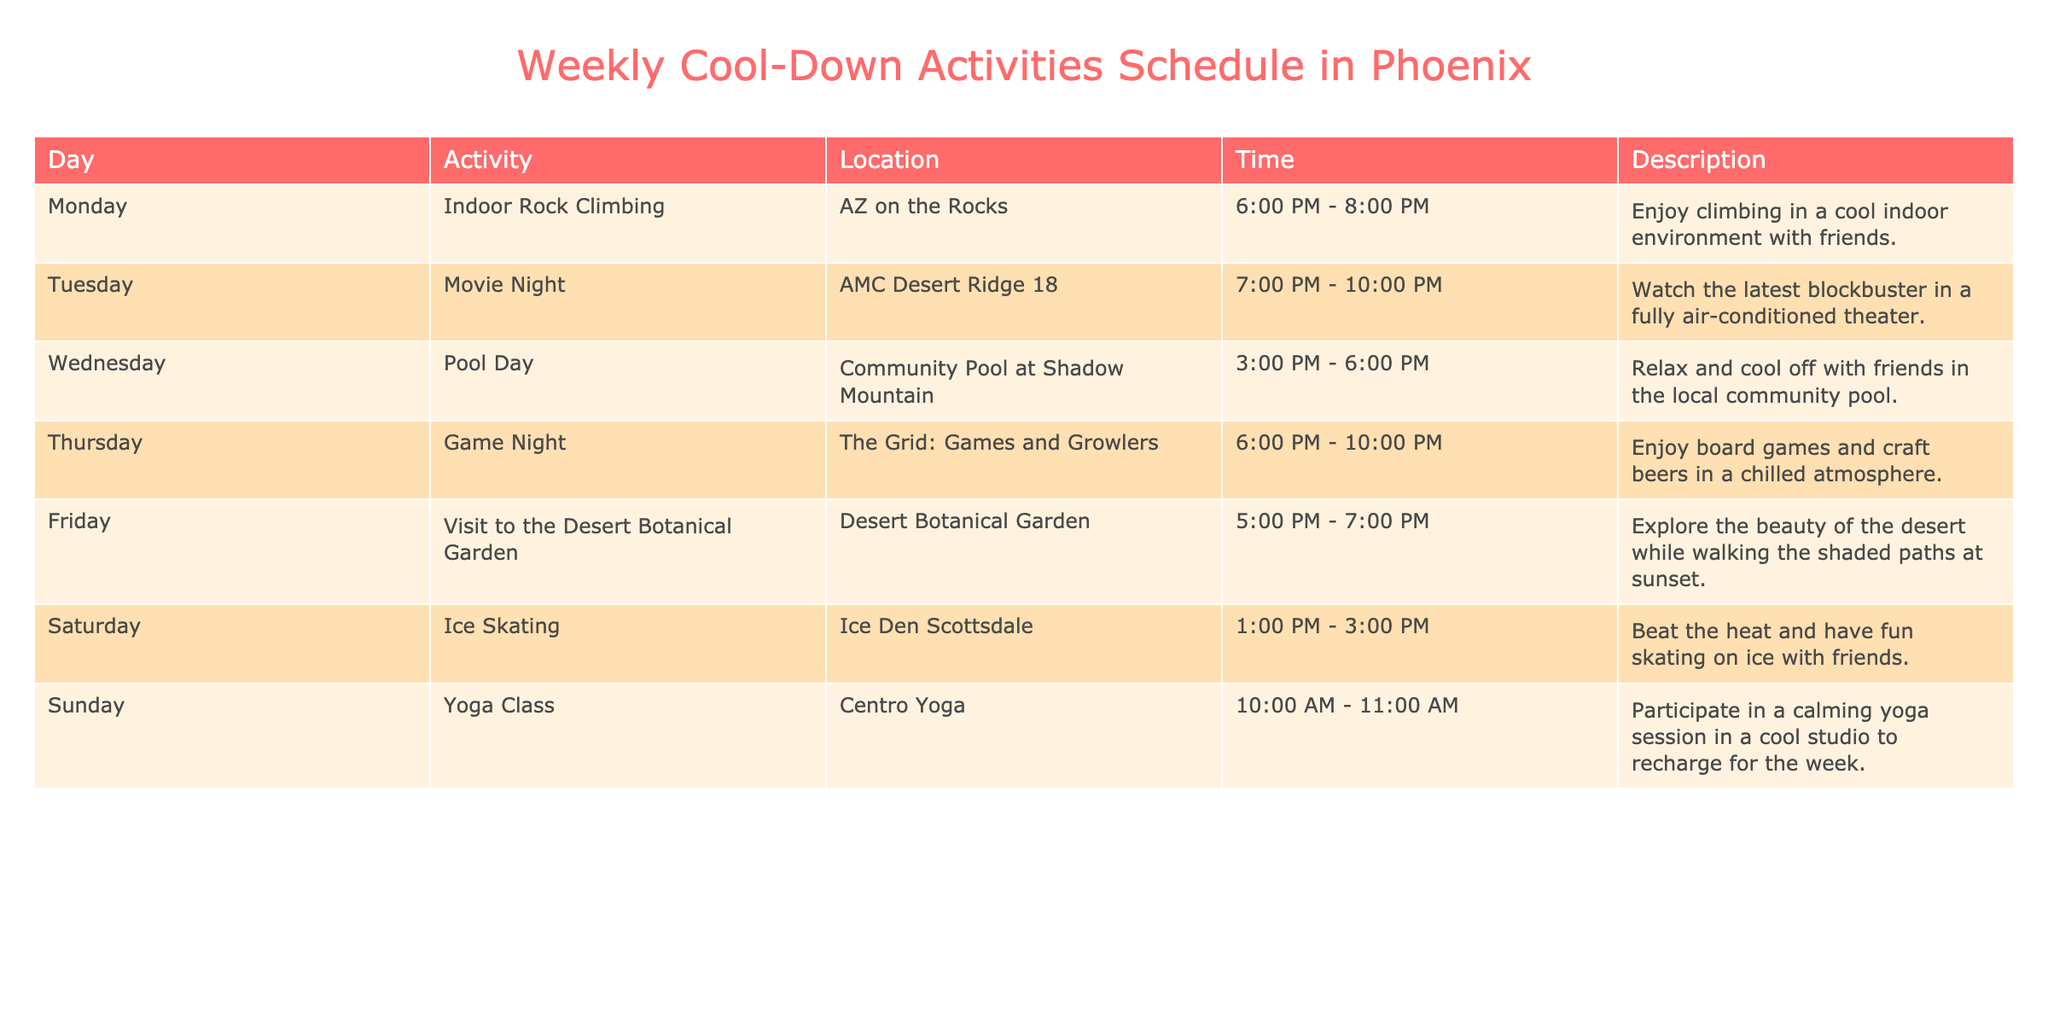What activity is scheduled for Saturday? The table lists the activities by day. Looking at Saturday, the activity is "Ice Skating."
Answer: Ice Skating What time does the Game Night start? Referring to the row for Thursday, Game Night is scheduled to start at 6:00 PM.
Answer: 6:00 PM Is there a cool-down activity on Sunday? By checking the activities for Sunday in the table, there is indeed an activity listed - a Yoga Class.
Answer: Yes How many activities take place after 6:00 PM? From the table, Monday (Indoor Rock Climbing), Tuesday (Movie Night), Thursday (Game Night), and Friday (Visit to the Desert Botanical Garden) are all scheduled to start after 6:00 PM, totaling four activities.
Answer: 4 What is the difference in time between the start of the Pool Day and the Ice Skating activity? Pool Day starts at 3:00 PM and Ice Skating starts at 1:00 PM on Saturday. Calculating the difference, 3:00 PM (Pool Day) is 2 hours later than 1:00 PM (Ice Skating). Thus, the difference is 2 hours.
Answer: 2 hours How many activities are scheduled to take place in the evening (after 5:00 PM)? From the table, the activities happening after 5:00 PM include Indoor Rock Climbing (Monday), Movie Night (Tuesday), Visit to the Desert Botanical Garden (Friday), and Game Night (Thursday), totaling four evening activities.
Answer: 4 Which activity is taking place at the Desert Botanical Garden? Referring to the Friday entry in the table, the activity listed is “Visit to the Desert Botanical Garden.”
Answer: Visit to the Desert Botanical Garden Are all activities on weekdays? From the table data, there are activities listed for Monday through Sunday. Therefore, not all activities occur on weekdays; there are also weekend activities specified.
Answer: No What is the longest activity duration listed in the table? Evaluating the duration of each activity, the longest listed activity is Game Night, which goes from 6:00 PM to 10:00 PM, totaling 4 hours.
Answer: 4 hours 